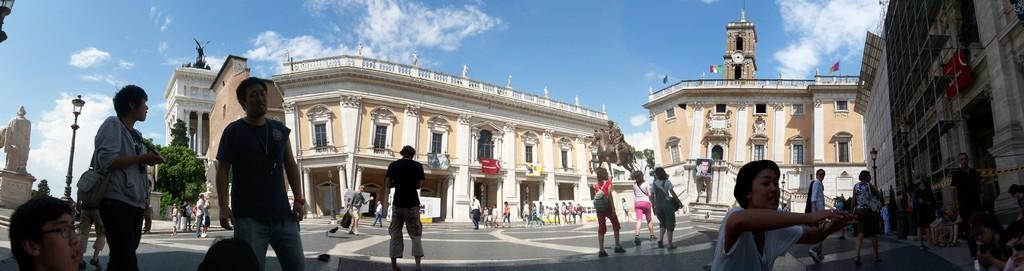Please provide a concise description of this image. In the background we can see the clouds in the sky, buildings, tress, windows, objects on the walls. We can see the statue of a man sitting on the horse, placed on a pedestal. In this picture we can see the people. Among them few are sitting, standing and walking. On the left side of the picture we can see another statue placed on a pedestal. We can see the lights. On the right side of the picture we can see a building, red board and a light pole. 